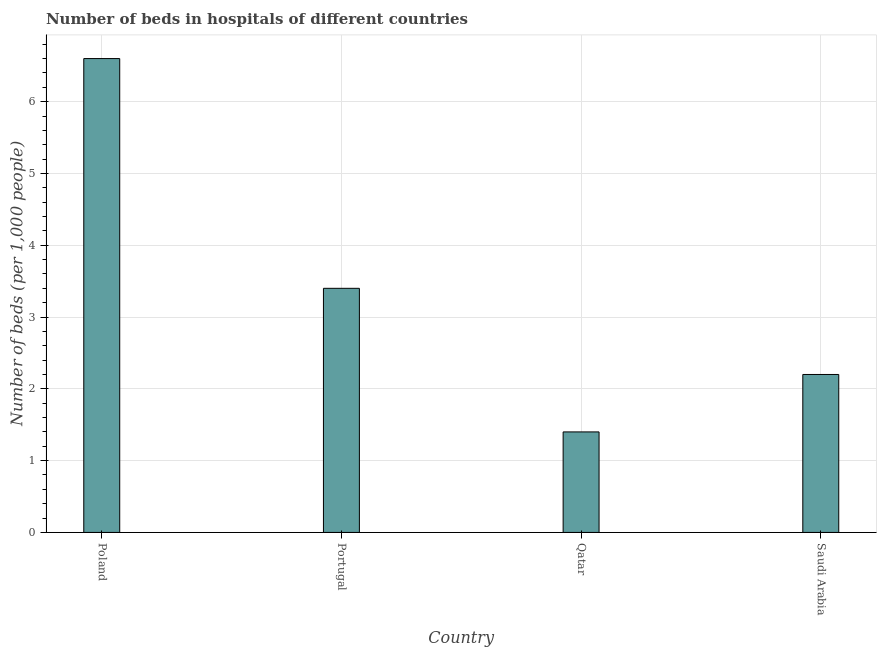Does the graph contain grids?
Offer a very short reply. Yes. What is the title of the graph?
Keep it short and to the point. Number of beds in hospitals of different countries. What is the label or title of the X-axis?
Offer a very short reply. Country. What is the label or title of the Y-axis?
Your response must be concise. Number of beds (per 1,0 people). What is the number of hospital beds in Poland?
Offer a very short reply. 6.6. Across all countries, what is the maximum number of hospital beds?
Provide a short and direct response. 6.6. Across all countries, what is the minimum number of hospital beds?
Provide a short and direct response. 1.4. In which country was the number of hospital beds minimum?
Provide a short and direct response. Qatar. What is the sum of the number of hospital beds?
Keep it short and to the point. 13.6. What is the ratio of the number of hospital beds in Portugal to that in Saudi Arabia?
Offer a terse response. 1.54. Is the difference between the number of hospital beds in Poland and Saudi Arabia greater than the difference between any two countries?
Your answer should be very brief. No. What is the difference between the highest and the second highest number of hospital beds?
Give a very brief answer. 3.2. What is the difference between two consecutive major ticks on the Y-axis?
Provide a short and direct response. 1. Are the values on the major ticks of Y-axis written in scientific E-notation?
Your response must be concise. No. What is the Number of beds (per 1,000 people) in Poland?
Your answer should be very brief. 6.6. What is the Number of beds (per 1,000 people) in Qatar?
Your answer should be compact. 1.4. What is the difference between the Number of beds (per 1,000 people) in Poland and Qatar?
Your response must be concise. 5.2. What is the ratio of the Number of beds (per 1,000 people) in Poland to that in Portugal?
Make the answer very short. 1.94. What is the ratio of the Number of beds (per 1,000 people) in Poland to that in Qatar?
Make the answer very short. 4.71. What is the ratio of the Number of beds (per 1,000 people) in Portugal to that in Qatar?
Make the answer very short. 2.43. What is the ratio of the Number of beds (per 1,000 people) in Portugal to that in Saudi Arabia?
Your response must be concise. 1.54. What is the ratio of the Number of beds (per 1,000 people) in Qatar to that in Saudi Arabia?
Provide a succinct answer. 0.64. 